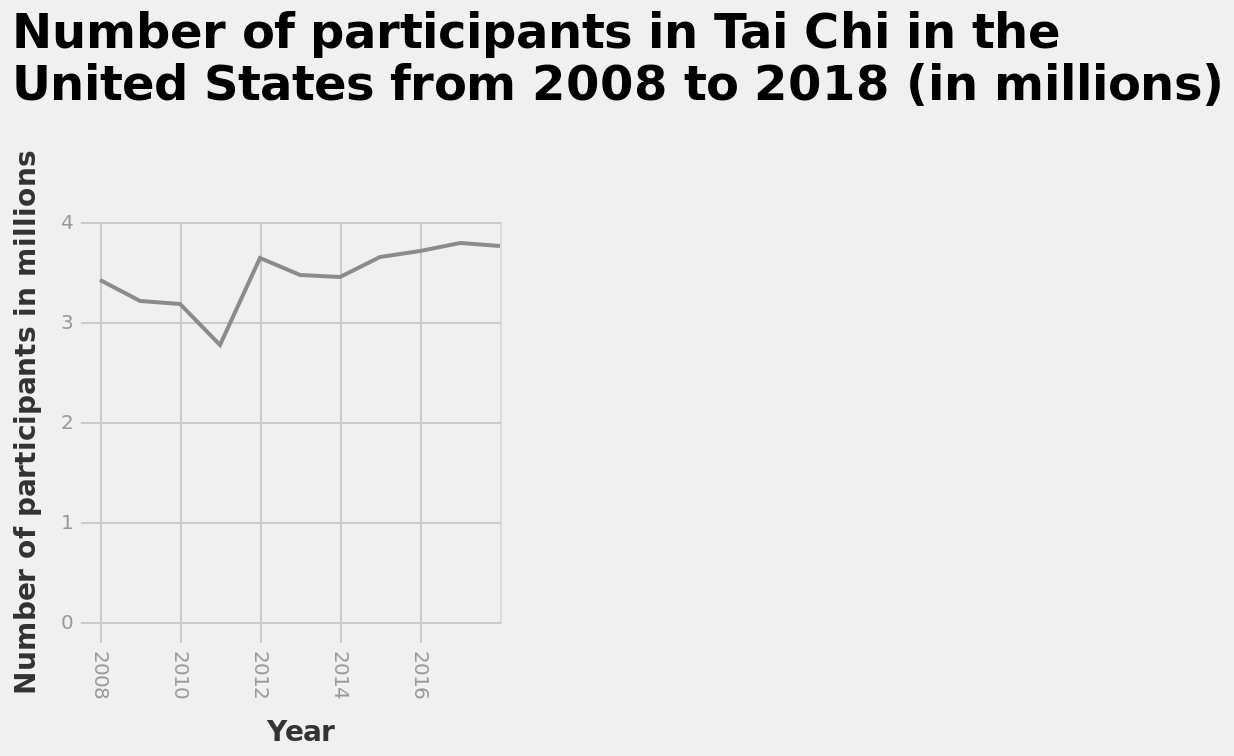<image>
please summary the statistics and relations of the chart There was a dip in participation in 2011, followed by a steep increase. Overall the rate has stayed fairly static. What occurred after the dip in participation in 2011? There was a steep increase in participation. 